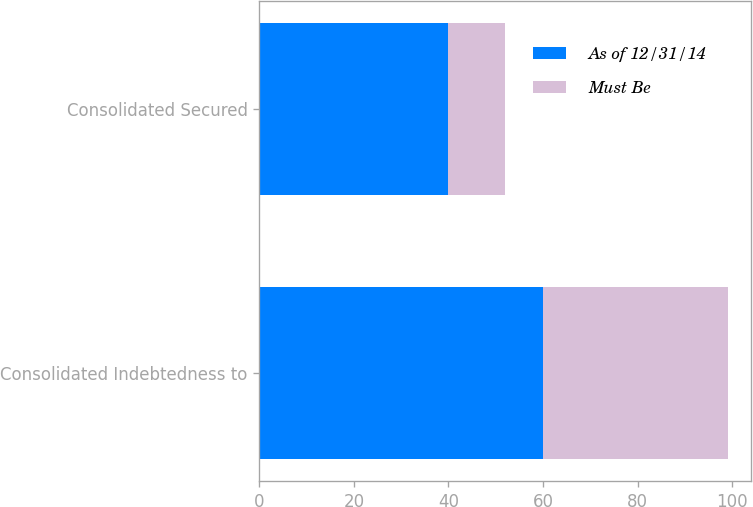Convert chart. <chart><loc_0><loc_0><loc_500><loc_500><stacked_bar_chart><ecel><fcel>Consolidated Indebtedness to<fcel>Consolidated Secured<nl><fcel>As of 12/31/14<fcel>60<fcel>40<nl><fcel>Must Be<fcel>39<fcel>12<nl></chart> 